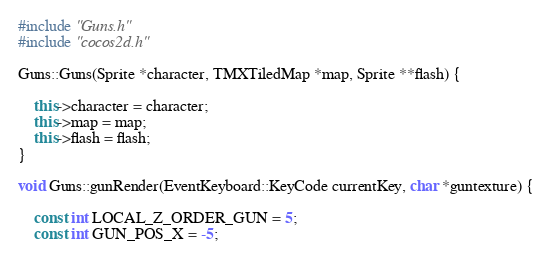<code> <loc_0><loc_0><loc_500><loc_500><_C++_>#include "Guns.h"
#include "cocos2d.h"

Guns::Guns(Sprite *character, TMXTiledMap *map, Sprite **flash) {
	
	this->character = character;
	this->map = map;
	this->flash = flash;
}

void Guns::gunRender(EventKeyboard::KeyCode currentKey, char *guntexture) {

	const int LOCAL_Z_ORDER_GUN = 5;
	const int GUN_POS_X = -5;</code> 